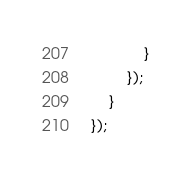Convert code to text. <code><loc_0><loc_0><loc_500><loc_500><_TypeScript_>            }
        });
    }
});
</code> 